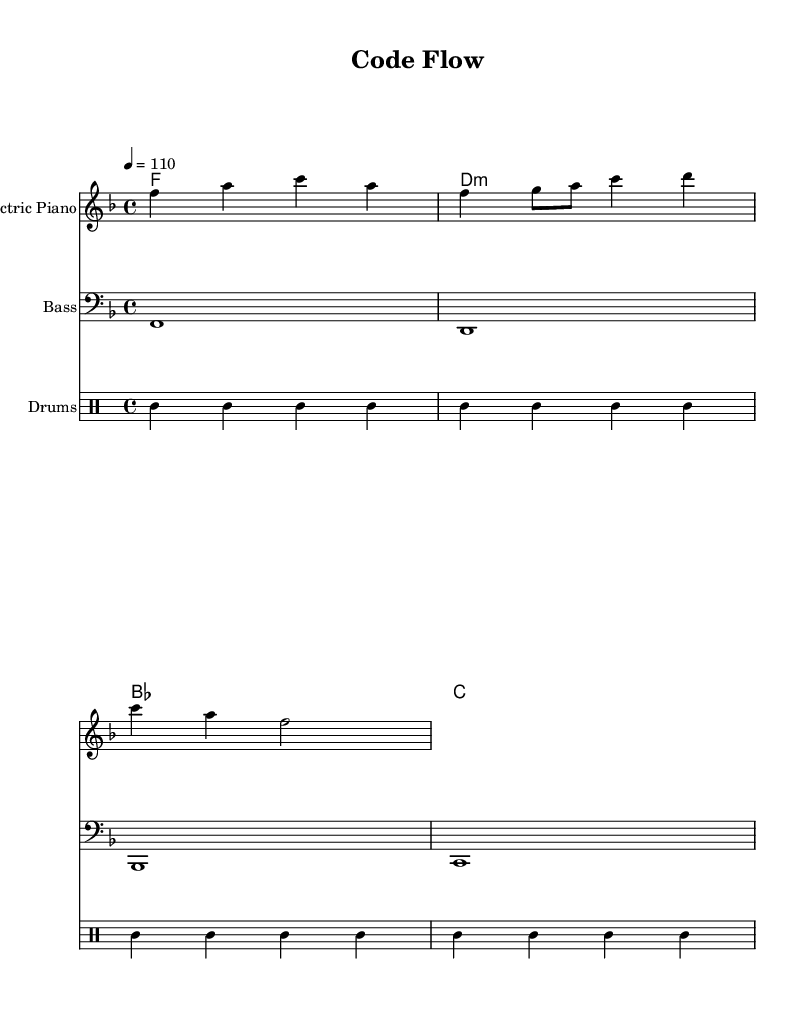What is the key signature of this music? The key signature is indicated at the beginning of the piece and shows that there is one flat, which indicates the key of F major.
Answer: F major What is the time signature of the piece? The time signature is found at the beginning and indicates that there are four beats in every measure, represented as 4/4.
Answer: 4/4 What is the tempo marking in this music? The tempo marking indicates the speed at which the piece should be played and is written as "4 = 110," meaning there are 110 beats per minute for the quarter note.
Answer: 110 How many measures are in the melody? By counting the musical phrases in the melody section, there are a total of three measures present.
Answer: 3 What type of instruments are used in this score? The instruments are listed at the beginning of each staff, and they include Electric Piano, Bass, and Drums.
Answer: Electric Piano, Bass, Drums What is the first chord played in this piece? The first chord is clearly indicated in the chord names section and is labeled as F major, which is the chord played in the first measure.
Answer: F Which rhythmic pattern is predominantly used in the drums section? Observing the drum pattern, the bass drum and snare are consistently alternated, with a repeating pattern that emphasizes backbeat on the snare; this characteristic is typical in R&B styles.
Answer: BD, HH, SN 